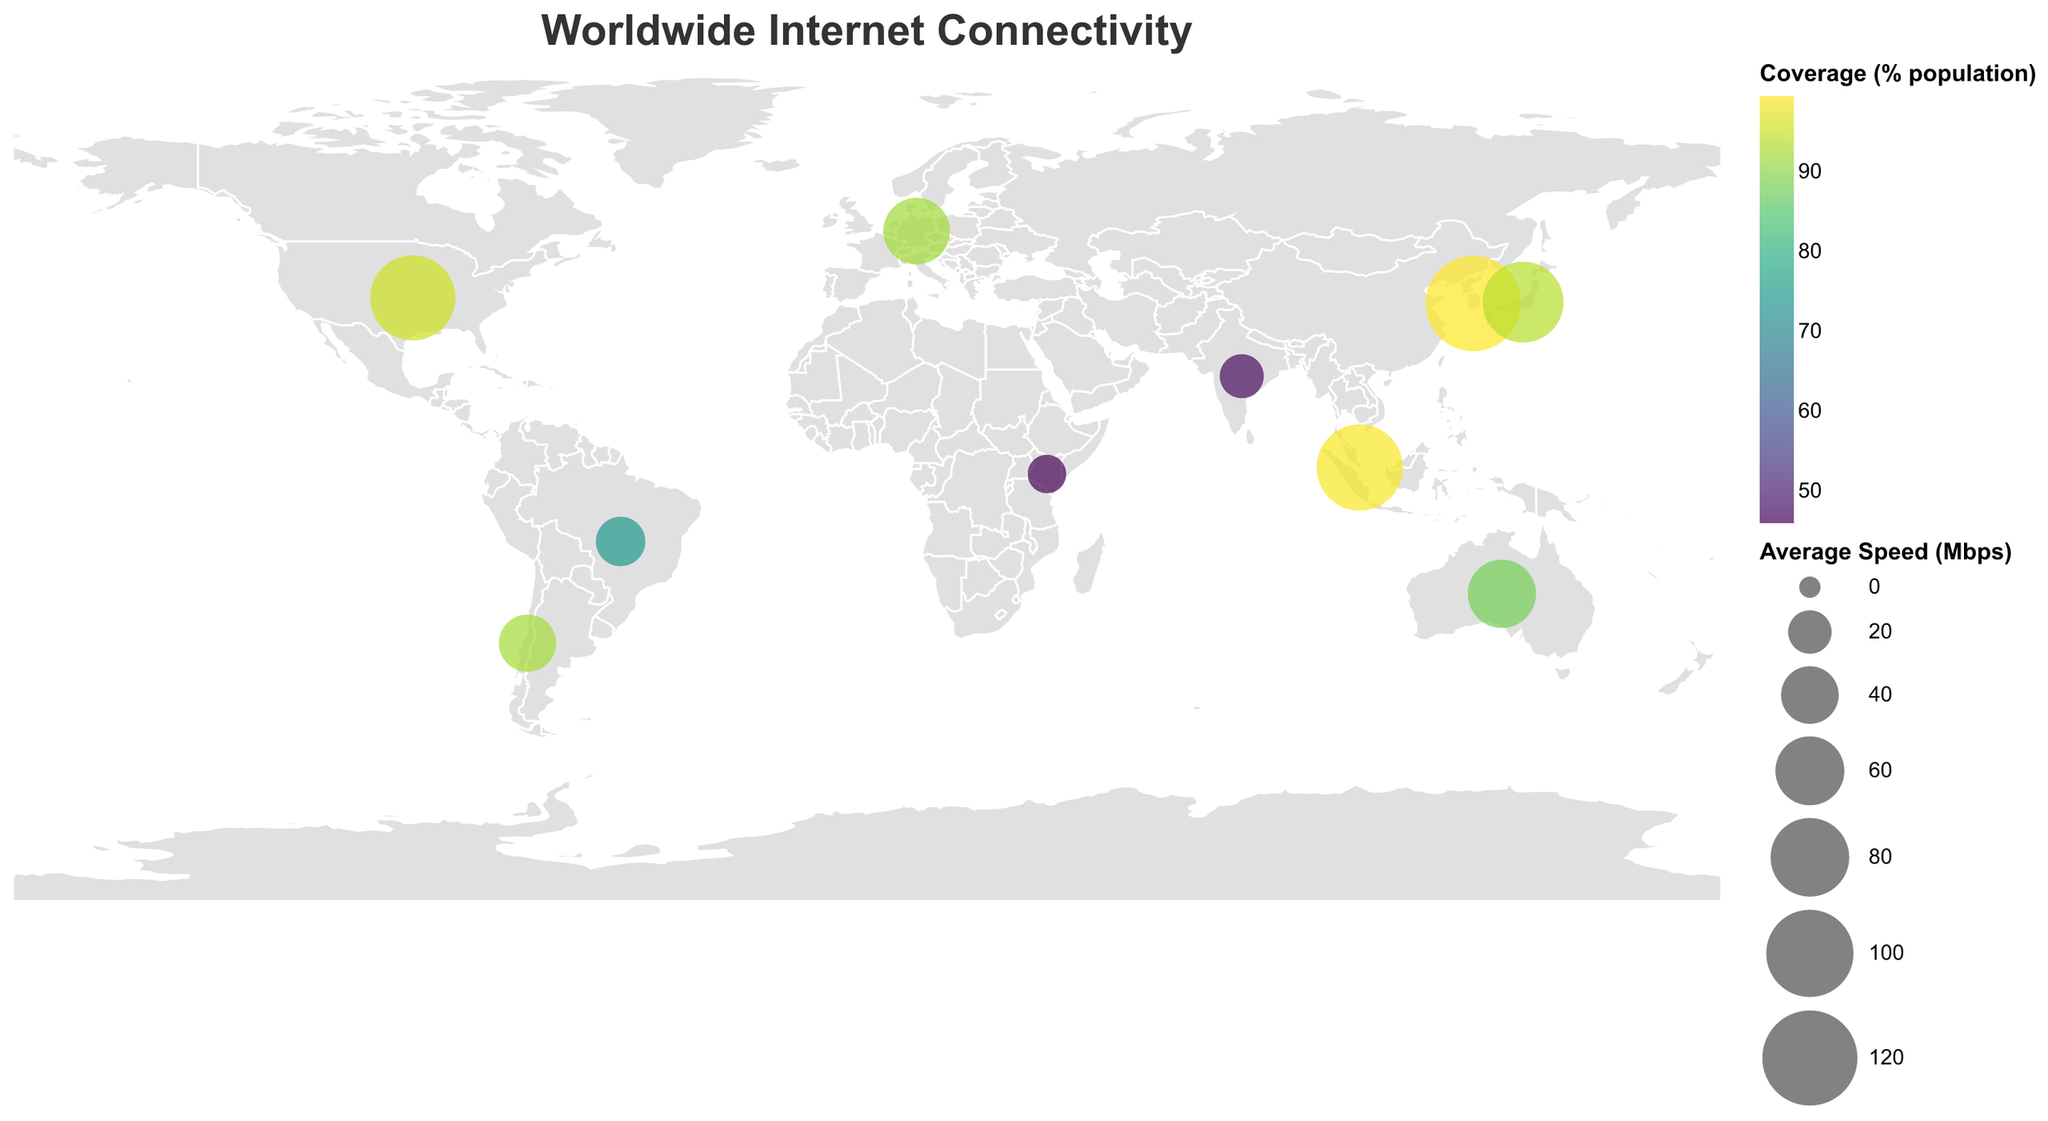Which country has the highest internet coverage percentage? The figure shows circles with varying sizes and colors. The color intensity represents the coverage percentage. By identifying the country with the most intense color, you can infer it represents the highest internet coverage percentage. South Korea, with the most intense (darkest) color, has the highest coverage percentage.
Answer: South Korea What's the average internet speed in Japan? The figure allows us to see the data points with each country's specific internet speed. By locating the circle for Japan on the map, the figure indicates Japan's internet speed as 85.02 Mbps.
Answer: 85.02 Mbps Which country has the slowest average internet speed? The size of the circles on the map represents the average internet speed; the smallest circle indicates the slowest speed. Kenya has the smallest circle, hence, the slowest average internet speed at 14.30 Mbps.
Answer: Kenya Compare the average internet speeds between Chile and Brazil. Which country has a higher speed? By referring to the circles representing Chile and Brazil, their average internet speeds can be compared directly. Chile has an average speed of 39.58 Mbps, while Brazil has 27.81 Mbps. Therefore, Chile has higher internet speed.
Answer: Chile Which country has a coverage percentage similar to Germany's? Germany's coverage percentage can be used as a reference to find another country with a similar value. Germany has 92.0% coverage. Upon inspecting the colors, Japan (93.7%) closely matches Germany’s figure.
Answer: Japan What's the average coverage percentage for India, Kenya, and Brazil combined? First, find the coverage percentages: India (47.5%), Kenya (46.0%), and Brazil (74.7%). Sum these values (47.5 + 46.0 + 74.7 = 168.2) and divide by 3. The average is 168.2/3 = 56.07%.
Answer: 56.07% How does South Korea's internet speed compare to the United States'? Locate the circles for South Korea and the United States on the map. South Korea has an average speed of 121.01 Mbps, while the United States has 94.83 Mbps. South Korea has a higher internet speed.
Answer: South Korea Which country could be considered as having the most potential for improvement in internet speed and coverage? Compare the countries with lower values in both speed and coverage to identify which has room for significant improvement. India has an average speed of 20.69 Mbps and 47.5% coverage and is labeled as "Rapidly improving," suggesting significant potential.
Answer: India What is the subjective rating for Australia's internet connectivity? The map's tooltip or data info reflects Australia's internet attributes, including its subjective rating. By navigating to its position, the figure shows Australia's subjective rating as "Decent but overpriced."
Answer: Decent but overpriced 